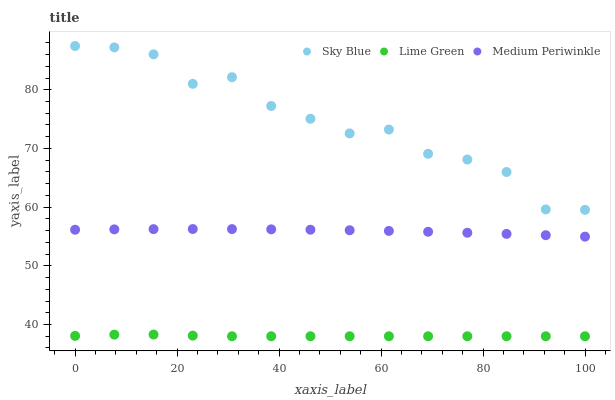Does Lime Green have the minimum area under the curve?
Answer yes or no. Yes. Does Sky Blue have the maximum area under the curve?
Answer yes or no. Yes. Does Medium Periwinkle have the minimum area under the curve?
Answer yes or no. No. Does Medium Periwinkle have the maximum area under the curve?
Answer yes or no. No. Is Medium Periwinkle the smoothest?
Answer yes or no. Yes. Is Sky Blue the roughest?
Answer yes or no. Yes. Is Lime Green the smoothest?
Answer yes or no. No. Is Lime Green the roughest?
Answer yes or no. No. Does Lime Green have the lowest value?
Answer yes or no. Yes. Does Medium Periwinkle have the lowest value?
Answer yes or no. No. Does Sky Blue have the highest value?
Answer yes or no. Yes. Does Medium Periwinkle have the highest value?
Answer yes or no. No. Is Medium Periwinkle less than Sky Blue?
Answer yes or no. Yes. Is Sky Blue greater than Lime Green?
Answer yes or no. Yes. Does Medium Periwinkle intersect Sky Blue?
Answer yes or no. No. 